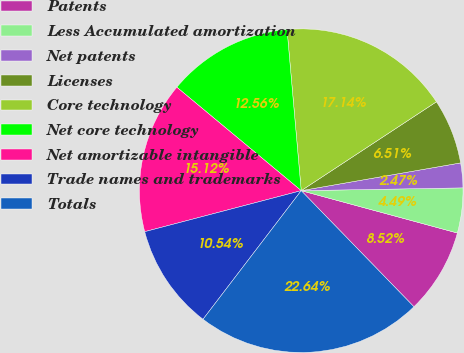Convert chart to OTSL. <chart><loc_0><loc_0><loc_500><loc_500><pie_chart><fcel>Patents<fcel>Less Accumulated amortization<fcel>Net patents<fcel>Licenses<fcel>Core technology<fcel>Net core technology<fcel>Net amortizable intangible<fcel>Trade names and trademarks<fcel>Totals<nl><fcel>8.52%<fcel>4.49%<fcel>2.47%<fcel>6.51%<fcel>17.14%<fcel>12.56%<fcel>15.12%<fcel>10.54%<fcel>22.64%<nl></chart> 